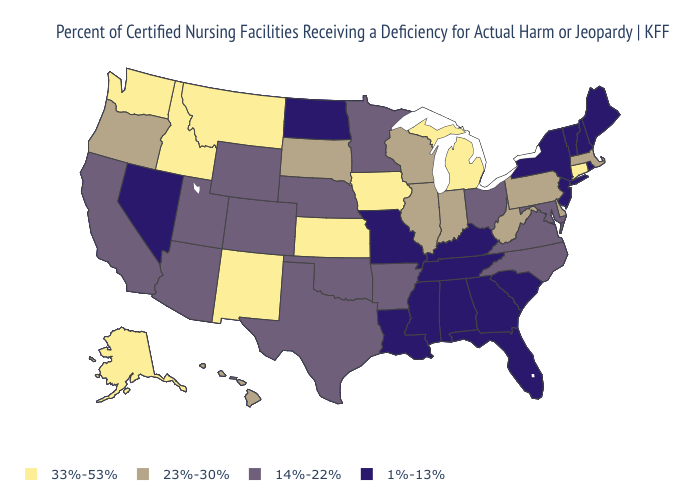What is the highest value in the South ?
Short answer required. 23%-30%. What is the lowest value in the USA?
Concise answer only. 1%-13%. What is the lowest value in the Northeast?
Be succinct. 1%-13%. What is the value of New Jersey?
Answer briefly. 1%-13%. Which states have the lowest value in the USA?
Keep it brief. Alabama, Florida, Georgia, Kentucky, Louisiana, Maine, Mississippi, Missouri, Nevada, New Hampshire, New Jersey, New York, North Dakota, Rhode Island, South Carolina, Tennessee, Vermont. What is the lowest value in the South?
Quick response, please. 1%-13%. What is the highest value in states that border California?
Concise answer only. 23%-30%. Does New York have the lowest value in the USA?
Write a very short answer. Yes. Does Arizona have a higher value than Ohio?
Keep it brief. No. What is the lowest value in the USA?
Quick response, please. 1%-13%. What is the lowest value in the West?
Quick response, please. 1%-13%. Name the states that have a value in the range 23%-30%?
Write a very short answer. Delaware, Hawaii, Illinois, Indiana, Massachusetts, Oregon, Pennsylvania, South Dakota, West Virginia, Wisconsin. Name the states that have a value in the range 14%-22%?
Be succinct. Arizona, Arkansas, California, Colorado, Maryland, Minnesota, Nebraska, North Carolina, Ohio, Oklahoma, Texas, Utah, Virginia, Wyoming. What is the value of Kentucky?
Concise answer only. 1%-13%. 